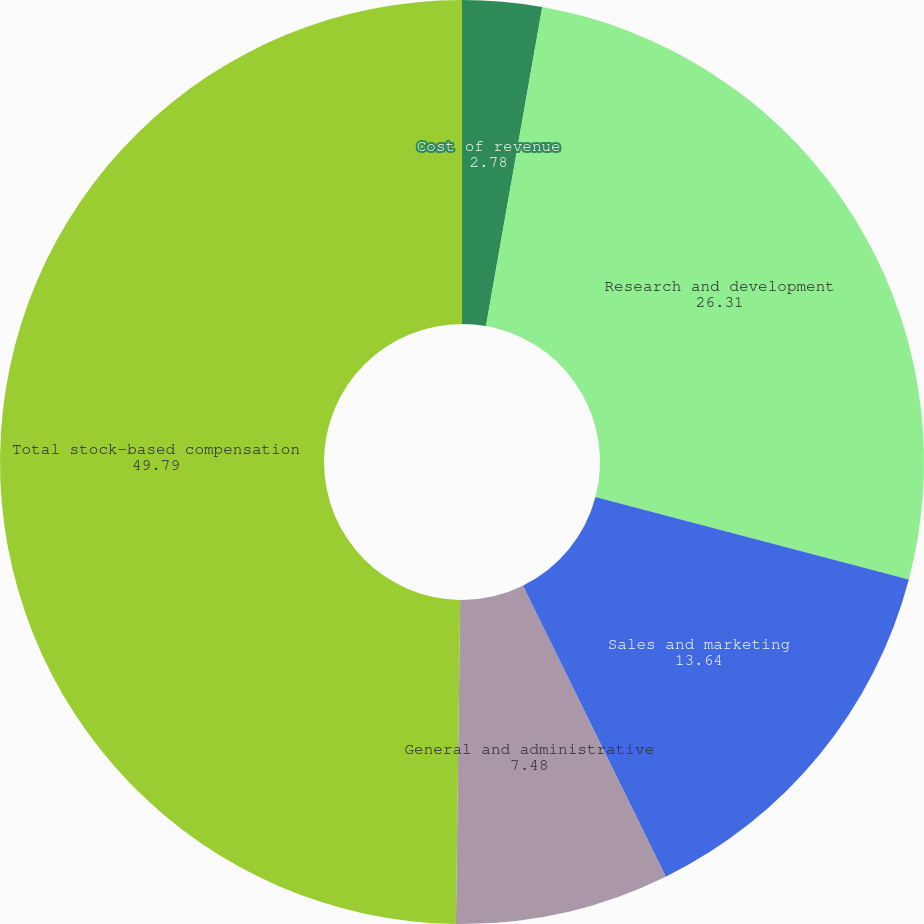Convert chart to OTSL. <chart><loc_0><loc_0><loc_500><loc_500><pie_chart><fcel>Cost of revenue<fcel>Research and development<fcel>Sales and marketing<fcel>General and administrative<fcel>Total stock-based compensation<nl><fcel>2.78%<fcel>26.31%<fcel>13.64%<fcel>7.48%<fcel>49.79%<nl></chart> 